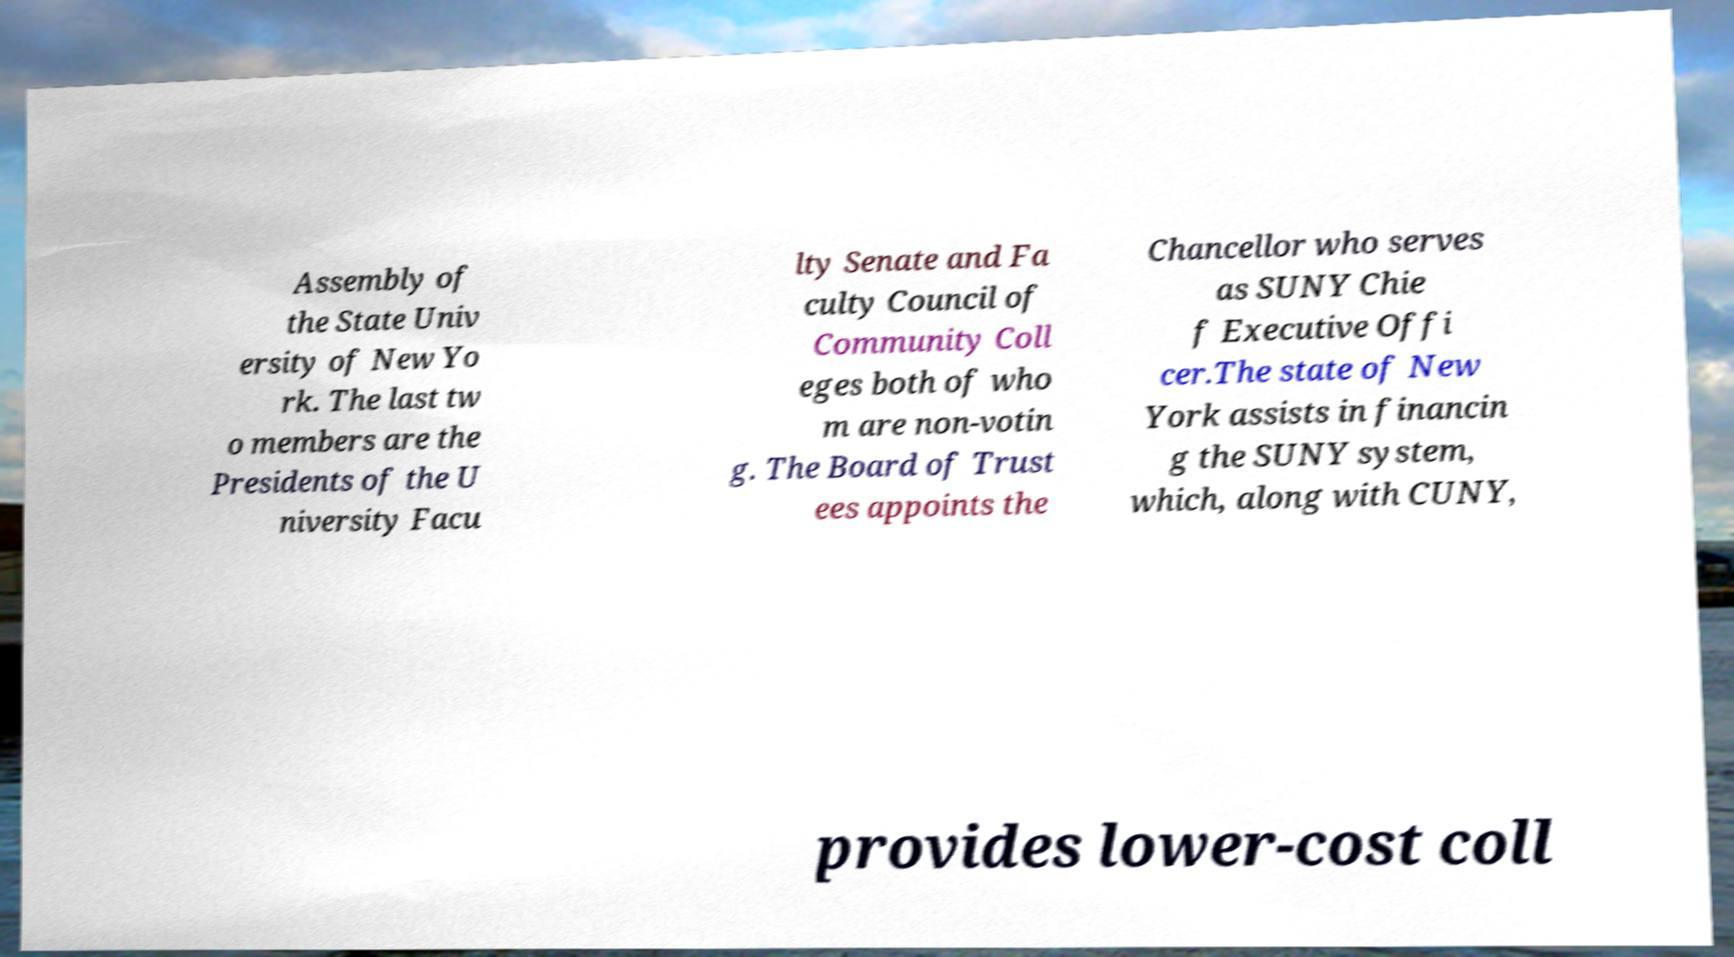What messages or text are displayed in this image? I need them in a readable, typed format. Assembly of the State Univ ersity of New Yo rk. The last tw o members are the Presidents of the U niversity Facu lty Senate and Fa culty Council of Community Coll eges both of who m are non-votin g. The Board of Trust ees appoints the Chancellor who serves as SUNY Chie f Executive Offi cer.The state of New York assists in financin g the SUNY system, which, along with CUNY, provides lower-cost coll 